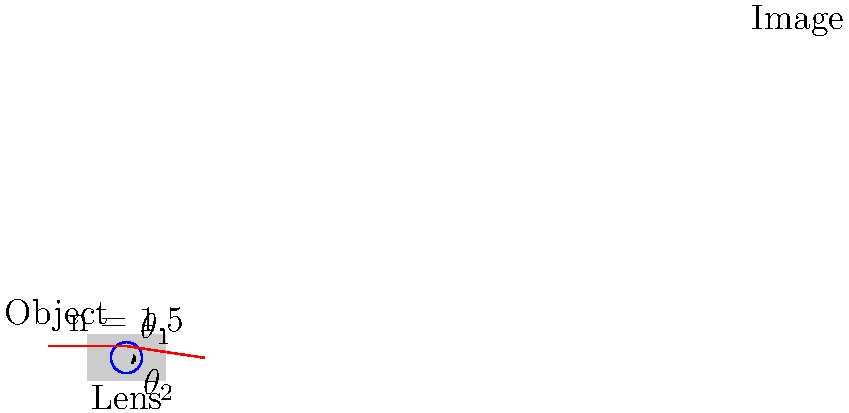In Taylor Swift's music video for "Wildest Dreams," the cinematographer uses a high-quality camera with a glass lens (refractive index $n = 1.5$). A light ray from the savannah landscape enters the lens at an angle of incidence $\theta_1 = 30°$. Using Snell's law, calculate the angle of refraction $\theta_2$ inside the lens. How might this refraction affect the dreamy, cinematic quality of the video? Let's approach this step-by-step, imagining we're analyzing the optics behind Taylor Swift's music video:

1) We're given:
   - Refractive index of the lens, $n = 1.5$
   - Angle of incidence, $\theta_1 = 30°$

2) We need to use Snell's law to find the angle of refraction, $\theta_2$. Snell's law states:

   $$n_1 \sin(\theta_1) = n_2 \sin(\theta_2)$$

   Where $n_1$ is the refractive index of air (approximately 1) and $n_2$ is the refractive index of the lens.

3) Substituting the values:

   $$1 \cdot \sin(30°) = 1.5 \cdot \sin(\theta_2)$$

4) Simplify:
   $$\sin(30°) = 1.5 \sin(\theta_2)$$
   $$0.5 = 1.5 \sin(\theta_2)$$

5) Solve for $\theta_2$:
   $$\sin(\theta_2) = \frac{0.5}{1.5} = \frac{1}{3}$$
   $$\theta_2 = \arcsin(\frac{1}{3}) \approx 19.47°$$

6) The angle of refraction is approximately 19.47°.

7) This refraction affects the video's dreamy quality by:
   - Bending light rays, which can create a soft focus effect
   - Potentially causing chromatic aberration, which can add a dreamy color fringe to bright edges
   - Allowing the cinematographer to control depth of field, creating a cinematic blur in out-of-focus areas
Answer: $\theta_2 \approx 19.47°$ 